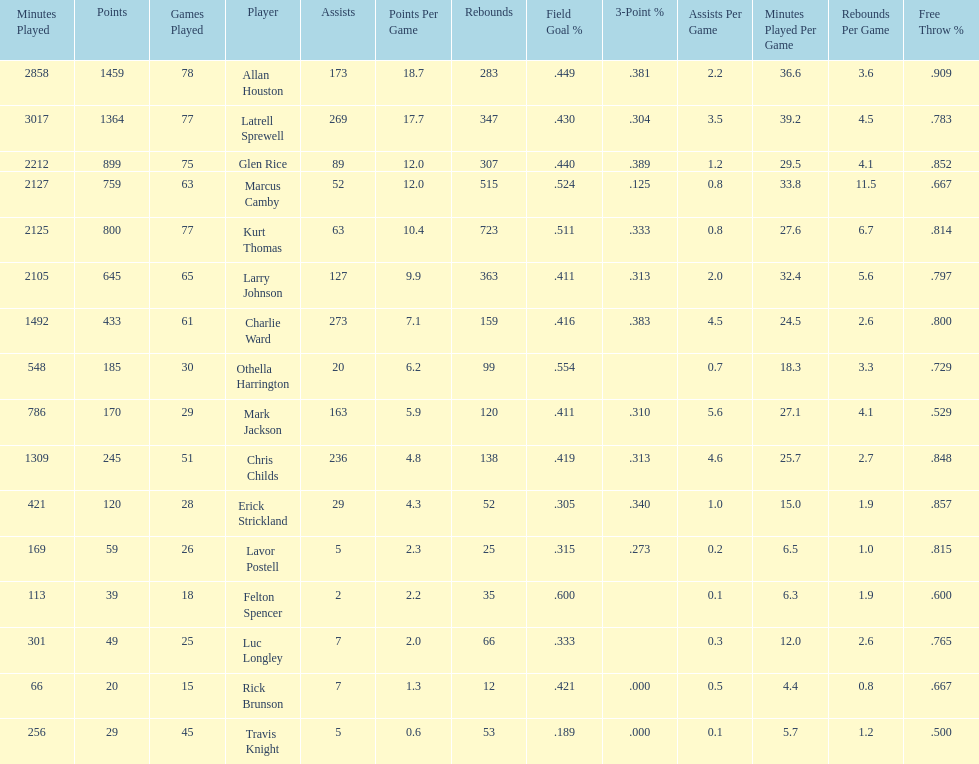How many total points were scored by players averaging over 4 assists per game> 848. 